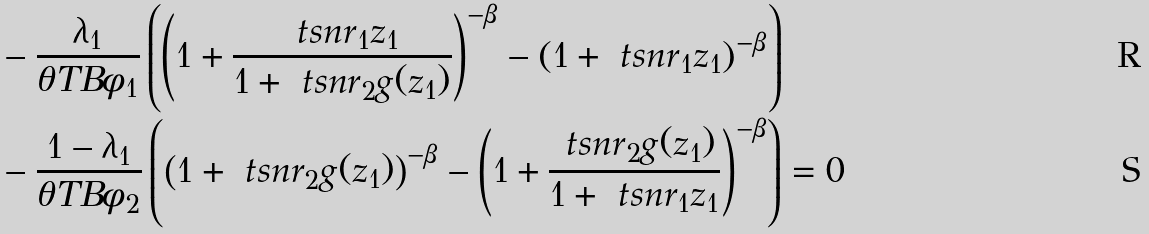<formula> <loc_0><loc_0><loc_500><loc_500>& - \frac { \lambda _ { 1 } } { \theta T B \phi _ { 1 } } \left ( \left ( 1 + \frac { \ t s n r _ { 1 } z _ { 1 } } { 1 + \ t s n r _ { 2 } g ( z _ { 1 } ) } \right ) ^ { - \beta } - \left ( 1 + \ t s n r _ { 1 } z _ { 1 } \right ) ^ { - \beta } \right ) \\ & - \frac { 1 - \lambda _ { 1 } } { \theta T B \phi _ { 2 } } \left ( \left ( 1 + \ t s n r _ { 2 } g ( z _ { 1 } ) \right ) ^ { - \beta } - \left ( 1 + \frac { \ t s n r _ { 2 } g ( z _ { 1 } ) } { 1 + \ t s n r _ { 1 } z _ { 1 } } \right ) ^ { - \beta } \right ) = 0</formula> 